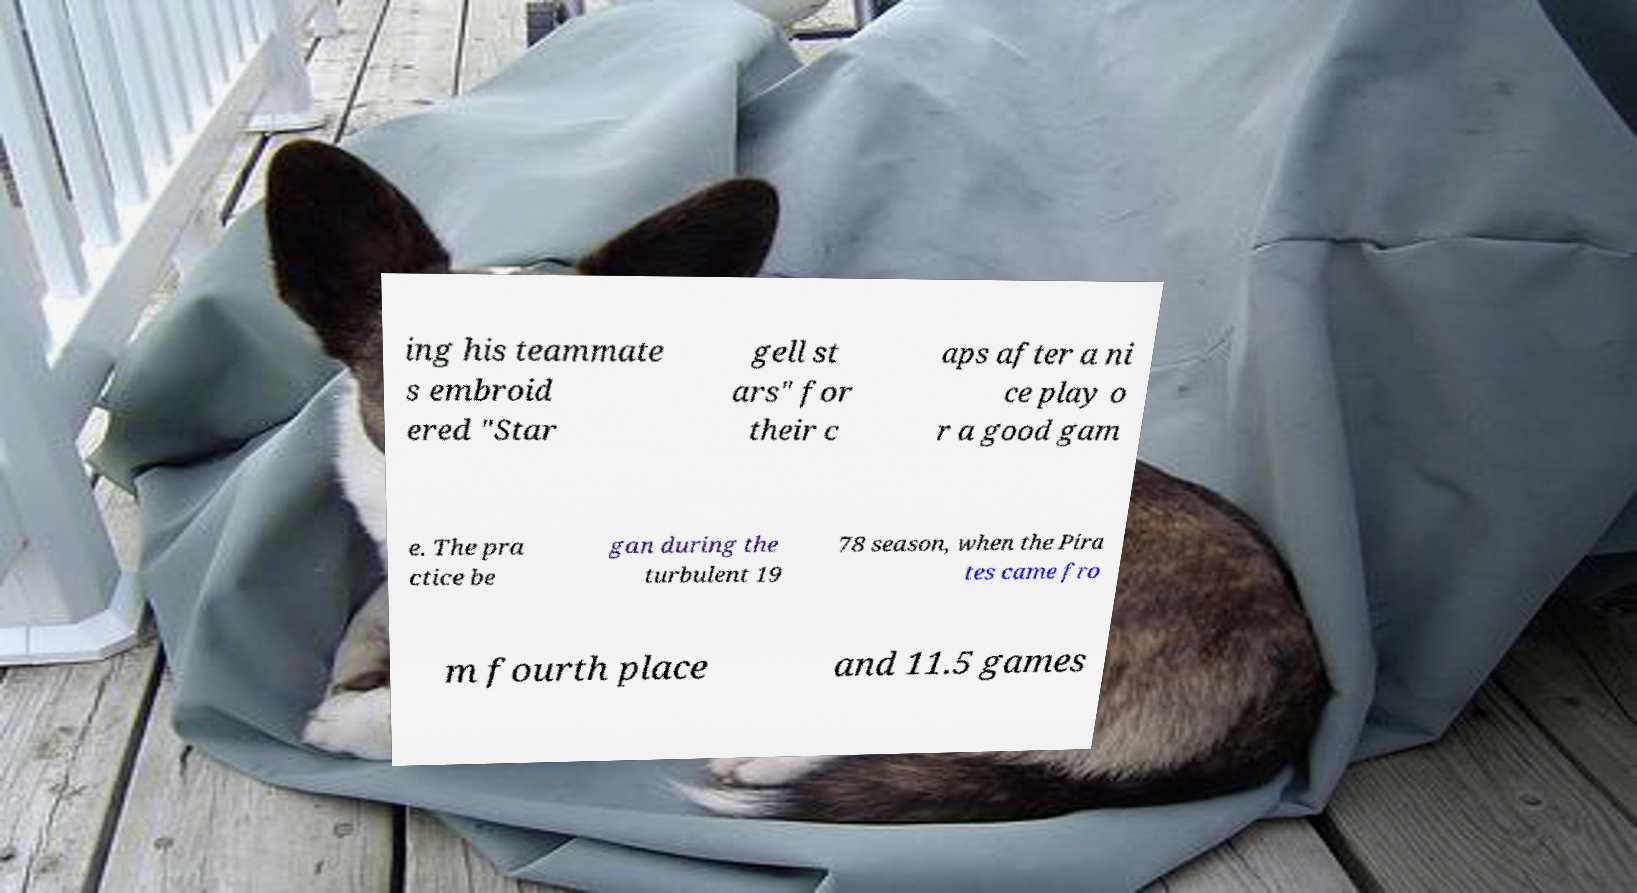Please identify and transcribe the text found in this image. ing his teammate s embroid ered "Star gell st ars" for their c aps after a ni ce play o r a good gam e. The pra ctice be gan during the turbulent 19 78 season, when the Pira tes came fro m fourth place and 11.5 games 